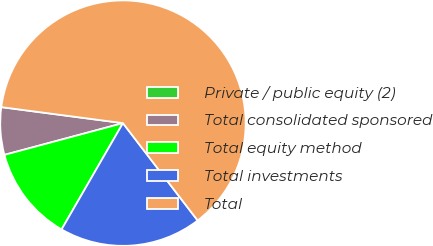Convert chart. <chart><loc_0><loc_0><loc_500><loc_500><pie_chart><fcel>Private / public equity (2)<fcel>Total consolidated sponsored<fcel>Total equity method<fcel>Total investments<fcel>Total<nl><fcel>0.0%<fcel>6.25%<fcel>12.5%<fcel>18.75%<fcel>62.5%<nl></chart> 